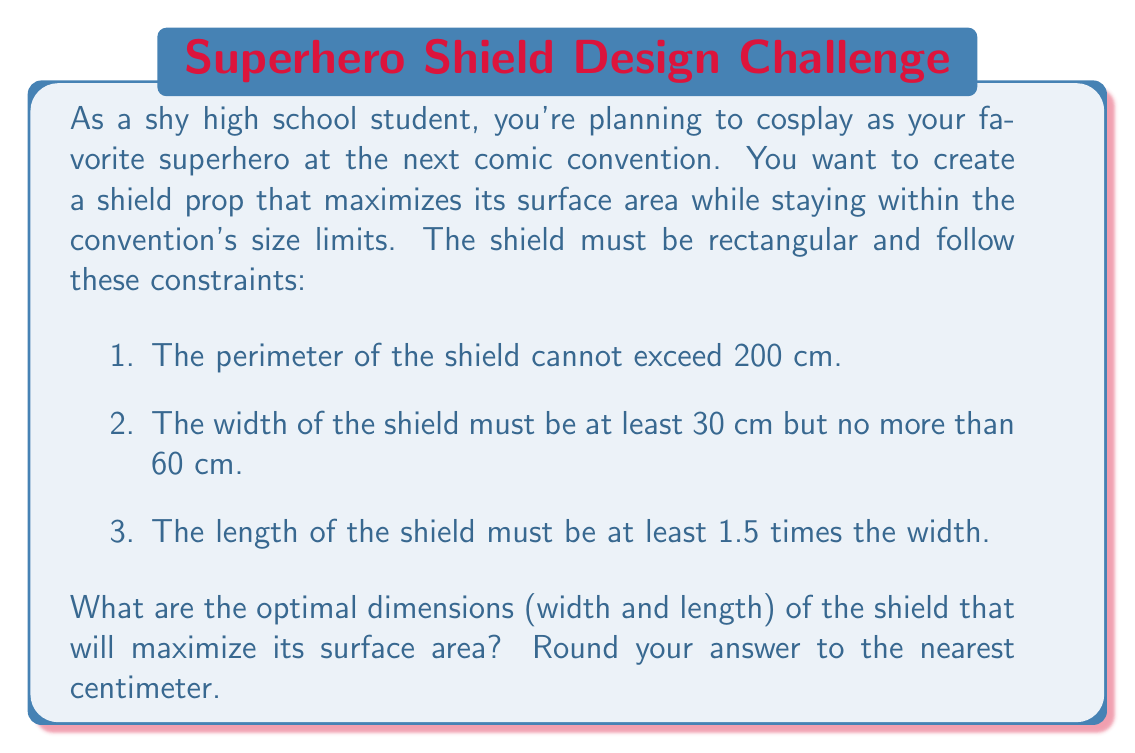Give your solution to this math problem. Let's approach this step-by-step:

1) Let $w$ be the width and $l$ be the length of the shield.

2) We need to maximize the area $A = w \cdot l$.

3) The constraints give us:
   
   $2w + 2l \leq 200$ (perimeter)
   $30 \leq w \leq 60$ (width limits)
   $l \geq 1.5w$ (length-width ratio)

4) From the perimeter constraint, we can express $l$ in terms of $w$:
   
   $l = 100 - w$

5) Now, we can express the area as a function of $w$:
   
   $A(w) = w(100-w) = 100w - w^2$

6) To find the maximum, we differentiate and set to zero:
   
   $$\frac{dA}{dw} = 100 - 2w = 0$$
   $$2w = 100$$
   $$w = 50$$

7) This gives us $w = 50$ and $l = 50$. However, we need to check if this satisfies all constraints:
   
   - Perimeter: $2(50) + 2(50) = 200$ (satisfies)
   - Width: $30 \leq 50 \leq 60$ (satisfies)
   - Length-width ratio: $50 \geq 1.5(50) = 75$ (does not satisfy)

8) Since the unconstrained maximum doesn't work, the optimal solution will be at the boundary of the length-width ratio constraint. Let's set $l = 1.5w$:

   $A(w) = w(1.5w) = 1.5w^2$
   
   Perimeter constraint: $2w + 2(1.5w) = 200$
   $5w = 200$
   $w = 40$

9) This gives us $w = 40$ and $l = 60$. Let's verify all constraints:
   
   - Perimeter: $2(40) + 2(60) = 200$ (satisfies)
   - Width: $30 \leq 40 \leq 60$ (satisfies)
   - Length-width ratio: $60 = 1.5(40)$ (satisfies)

Therefore, the optimal dimensions are width = 40 cm and length = 60 cm.
Answer: The optimal dimensions of the shield are 40 cm width and 60 cm length. 